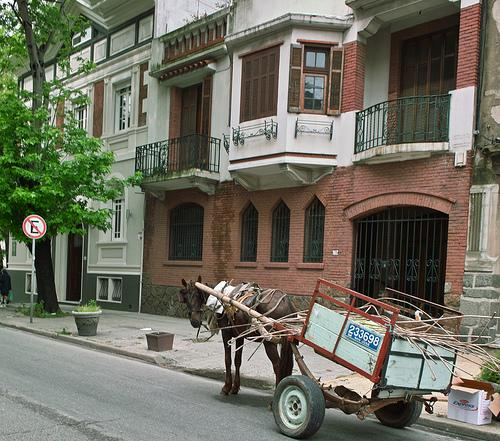Why is the horse attached to the cart with wheels? Please explain your reasoning. to pull. The cart is being pulled by the equine. 